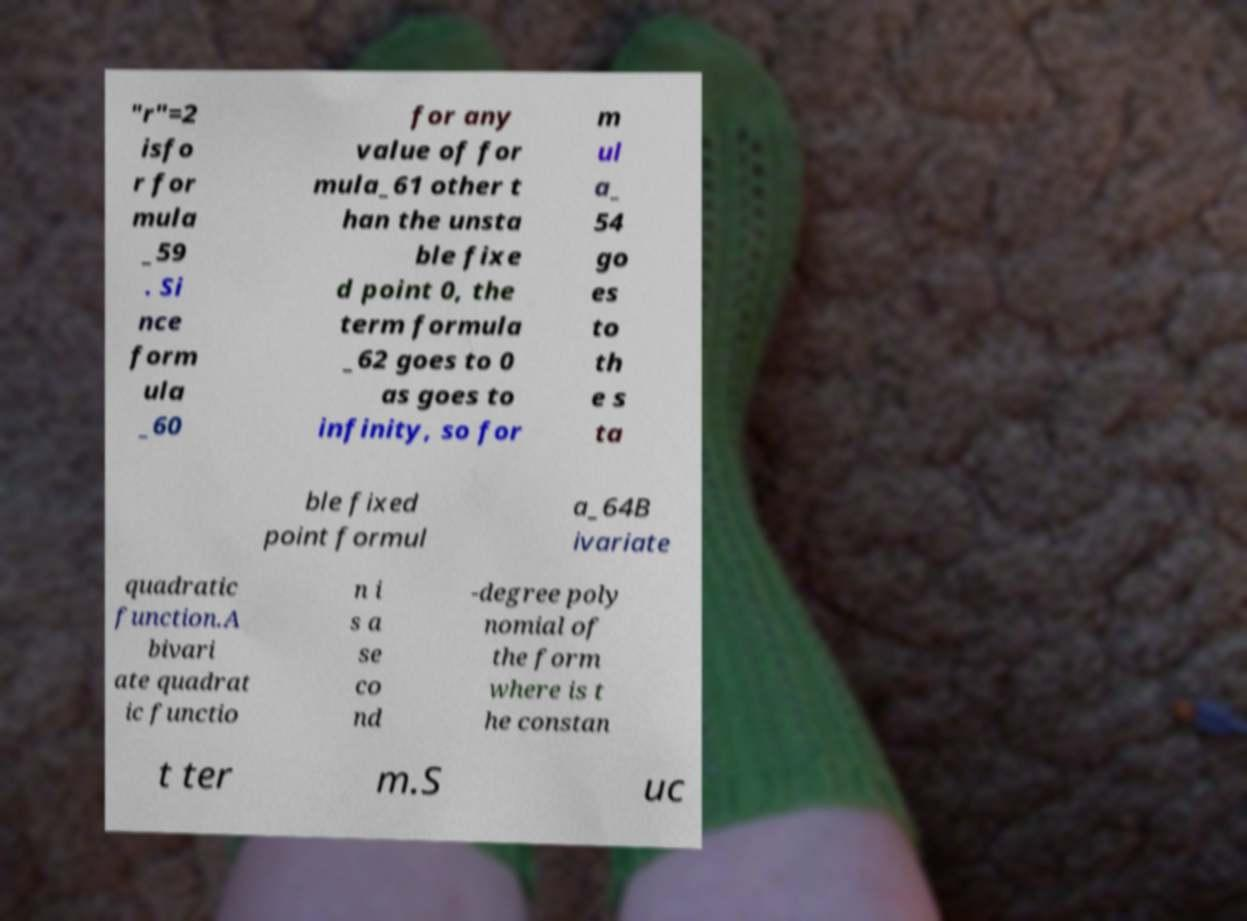Can you accurately transcribe the text from the provided image for me? "r"=2 isfo r for mula _59 . Si nce form ula _60 for any value of for mula_61 other t han the unsta ble fixe d point 0, the term formula _62 goes to 0 as goes to infinity, so for m ul a_ 54 go es to th e s ta ble fixed point formul a_64B ivariate quadratic function.A bivari ate quadrat ic functio n i s a se co nd -degree poly nomial of the form where is t he constan t ter m.S uc 